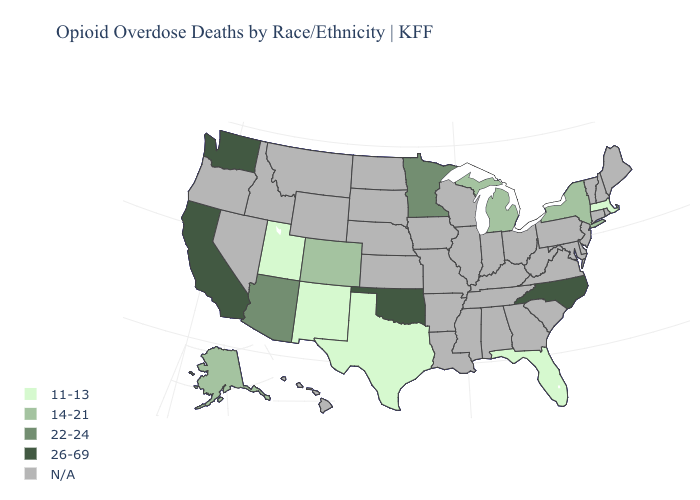Among the states that border Virginia , which have the lowest value?
Write a very short answer. North Carolina. Name the states that have a value in the range N/A?
Concise answer only. Alabama, Arkansas, Connecticut, Delaware, Georgia, Hawaii, Idaho, Illinois, Indiana, Iowa, Kansas, Kentucky, Louisiana, Maine, Maryland, Mississippi, Missouri, Montana, Nebraska, Nevada, New Hampshire, New Jersey, North Dakota, Ohio, Oregon, Pennsylvania, Rhode Island, South Carolina, South Dakota, Tennessee, Vermont, Virginia, West Virginia, Wisconsin, Wyoming. Among the states that border Kansas , which have the highest value?
Write a very short answer. Oklahoma. Does the first symbol in the legend represent the smallest category?
Quick response, please. Yes. Name the states that have a value in the range 22-24?
Short answer required. Arizona, Minnesota. Name the states that have a value in the range 11-13?
Concise answer only. Florida, Massachusetts, New Mexico, Texas, Utah. Name the states that have a value in the range 14-21?
Quick response, please. Alaska, Colorado, Michigan, New York. What is the lowest value in the MidWest?
Concise answer only. 14-21. What is the highest value in the Northeast ?
Quick response, please. 14-21. What is the value of Rhode Island?
Quick response, please. N/A. What is the value of Texas?
Be succinct. 11-13. Among the states that border Arizona , which have the lowest value?
Short answer required. New Mexico, Utah. Is the legend a continuous bar?
Concise answer only. No. 